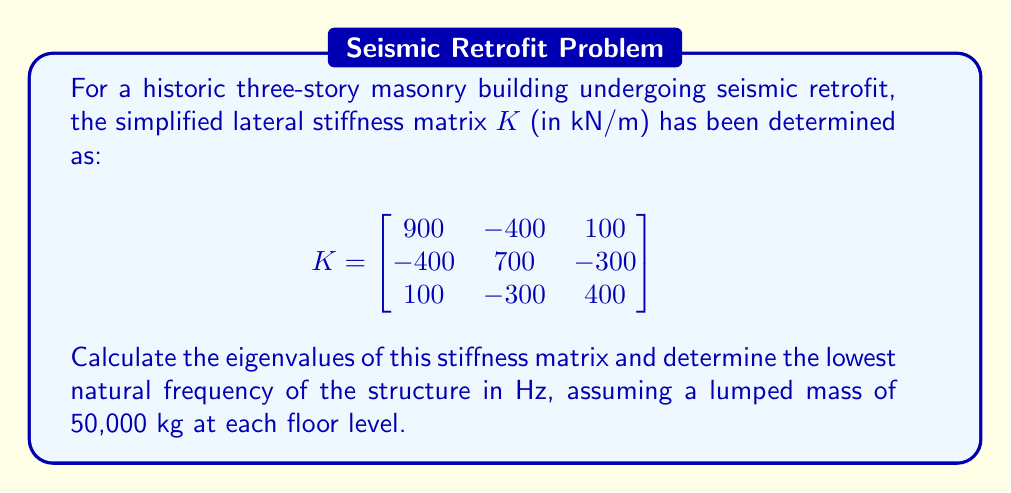Provide a solution to this math problem. 1) To find the eigenvalues, we need to solve the characteristic equation:
   $$det(K - \lambda I) = 0$$

2) Expanding the determinant:
   $$\begin{vmatrix}
   900-\lambda & -400 & 100 \\
   -400 & 700-\lambda & -300 \\
   100 & -300 & 400-\lambda
   \end{vmatrix} = 0$$

3) This yields the characteristic polynomial:
   $$-\lambda^3 + 2000\lambda^2 - 1,060,000\lambda + 120,000,000 = 0$$

4) Solving this cubic equation (using a computer algebra system or numerical methods) gives the eigenvalues:
   $$\lambda_1 \approx 1491.67 \text{ kN/m}$$
   $$\lambda_2 \approx 400.91 \text{ kN/m}$$
   $$\lambda_3 \approx 107.42 \text{ kN/m}$$

5) The lowest natural frequency corresponds to the smallest eigenvalue $\lambda_3$.

6) For a single degree of freedom system, the natural frequency is given by:
   $$f = \frac{1}{2\pi}\sqrt{\frac{k}{m}}$$

   where $k$ is the stiffness and $m$ is the mass.

7) Using $\lambda_3$ as $k$ and 50,000 kg as $m$:
   $$f = \frac{1}{2\pi}\sqrt{\frac{107,420 \text{ N/m}}{50,000 \text{ kg}}} \approx 0.74 \text{ Hz}$$
Answer: Eigenvalues: 1491.67, 400.91, 107.42 kN/m; Lowest natural frequency: 0.74 Hz 